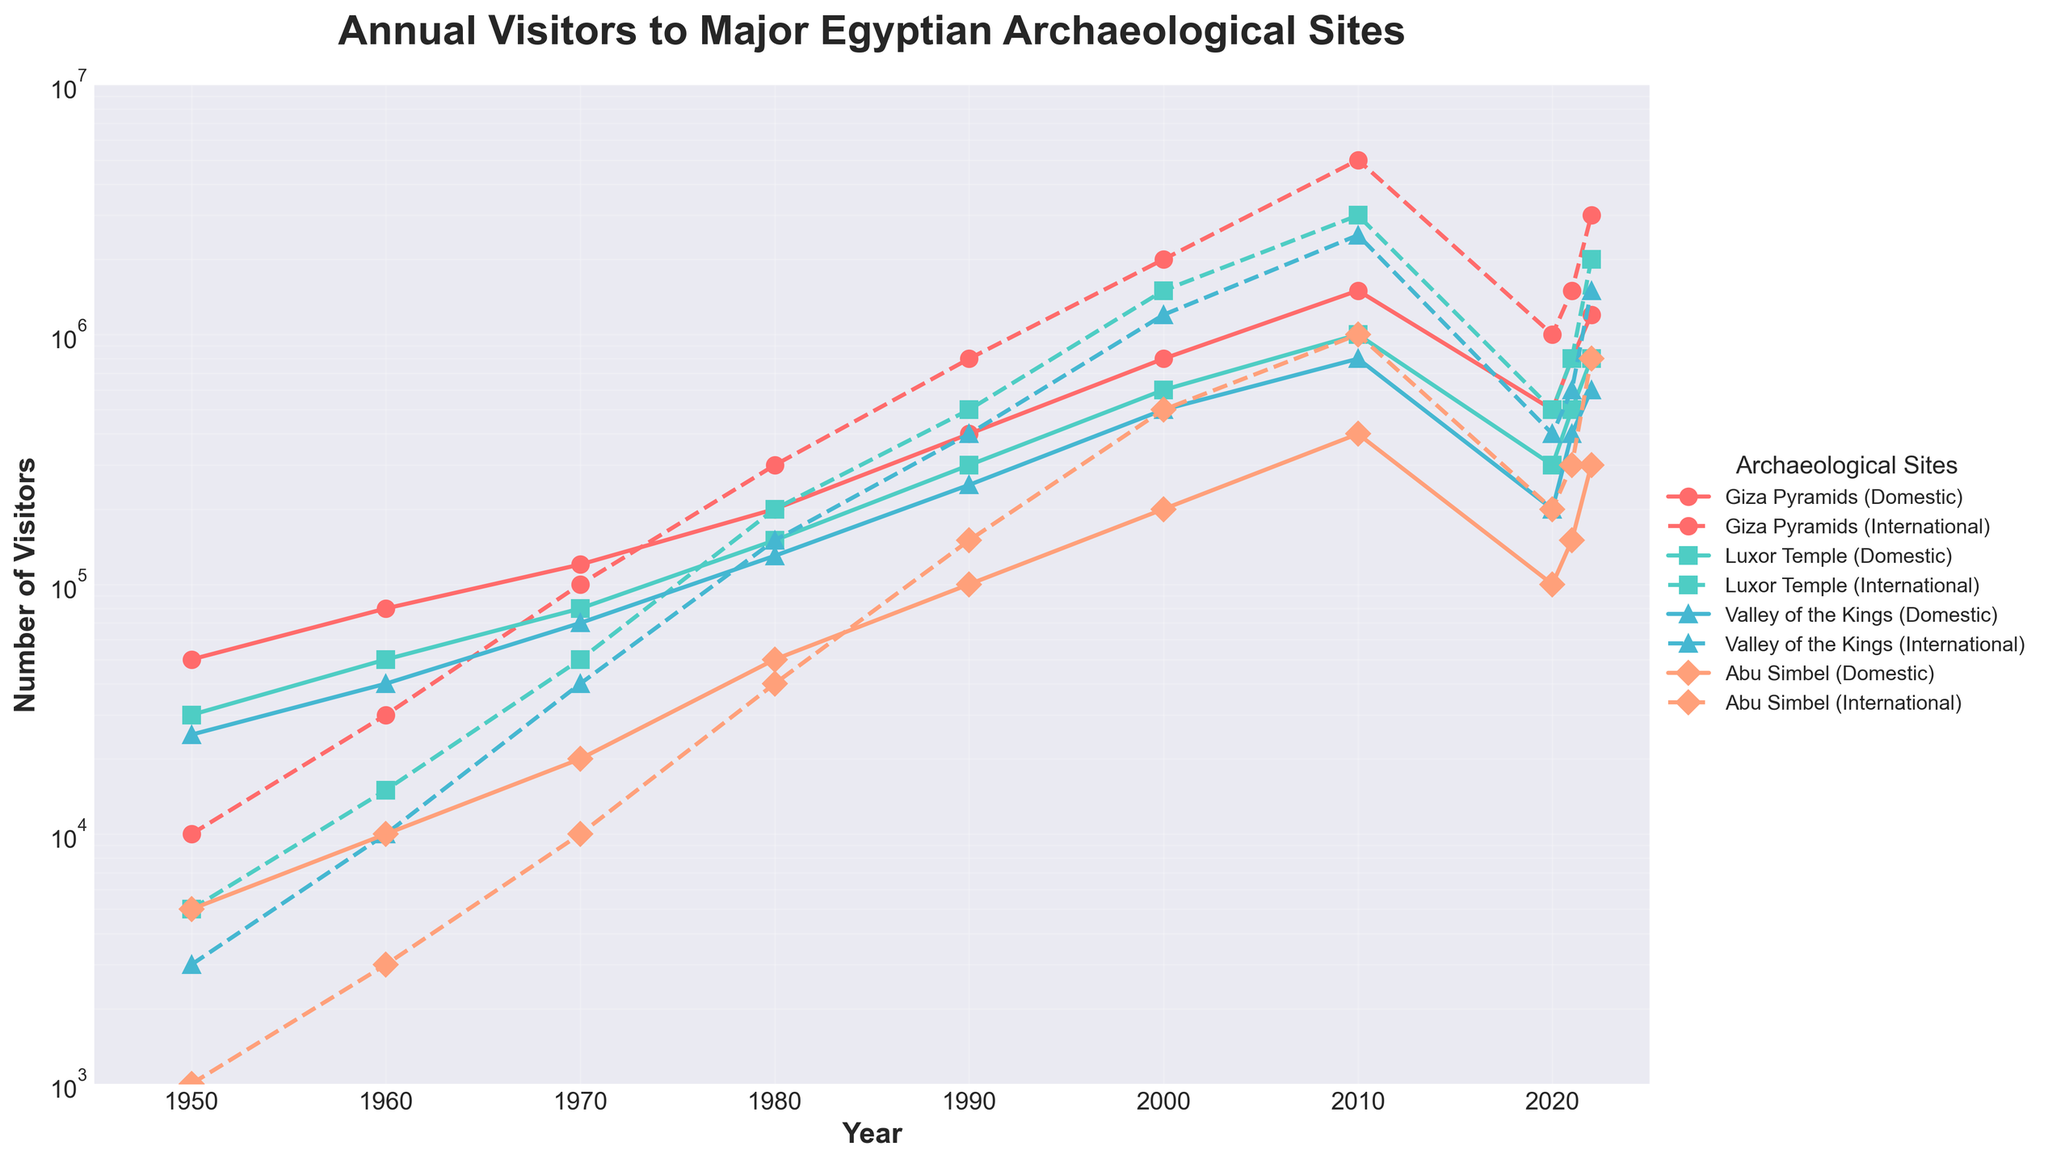What's the overall trend in visitor numbers to the Giza Pyramids from 1950 to 2022? Between 1950 and 2010, both domestic and international visitor numbers to the Giza Pyramids showed a significant upward trend, peaking in 2010. However, there was a noticeable decline in visitor numbers in 2020, followed by a recovery through 2022.
Answer: Upward trend with a peak in 2010 and a decline in 2020 Which site had the highest number of international visitors in any single year, and what was that number? The Giza Pyramids had the highest number of international visitors in 2010, with a count of 5,000,000.
Answer: The Giza Pyramids with 5,000,000 in 2010 How do the trends in domestic visitors to the Valley of the Kings compare with those to Abu Simbel from 1950 to 2022? Both the Valley of the Kings and Abu Simbel saw an overall increase in domestic visitors from 1950 to 2010. However, post-2010, the Valley of the Kings shows a sharp decline, whereas for Abu Simbel, the decline is less pronounced. Both then show some recovery through 2022.
Answer: Similar increasing trends with sharp declines post-2010 for both In which years did Luxor Temple have more domestic visitors than international visitors? Luxor Temple had more domestic visitors than international visitors in the years 1950, 1960, 1970, 1980, and 2021.
Answer: 1950, 1960, 1970, 1980, and 2021 What was the percentage increase in international visitors to Luxor Temple from 1990 to 2000? In 1990, Luxor Temple had 500,000 international visitors, and in 2000 it had 1,500,000. The percentage increase is calculated as: ((1,500,000 - 500,000) / 500,000) * 100 = 200%.
Answer: 200% How do the numbers of international visitors to the Giza Pyramids and the Valley of the Kings in 2022 compare? In 2022, the Giza Pyramids had 3,000,000 international visitors, while the Valley of the Kings had 1,500,000. This shows that the Giza Pyramids had twice as many international visitors as the Valley of the Kings.
Answer: Giza Pyramids had twice as many Which site saw the most significant relative increase in international visitors from 1950 to 2022? Abu Simbel saw the most significant relative increase in international visitors, going from 1,000 in 1950 to 800,000 in 2022. Calculating the relative increase: ((800,000 - 1,000) / 1,000) * 100 = 79,900%.
Answer: Abu Simbel During which decade did all sites see a noticeable increase in both domestic and international visitors? The 1980s saw a noticeable increase in both domestic and international visitors at all sites, as evident by the steep rise in the number of visitors during that period.
Answer: 1980s What is the average number of domestic visitors to Luxor Temple from 1950 to 2022? Adding the number of domestic visitors to Luxor Temple from 1950 (30,000), 1960 (50,000), 1970 (80,000), 1980 (150,000), 1990 (300,000), 2000 (600,000), 2010 (1,000,000), 2020 (300,000), 2021 (500,000), 2022 (800,000) gives 3,810,000. Dividing by 10 years gives 381,000.
Answer: 381,000 